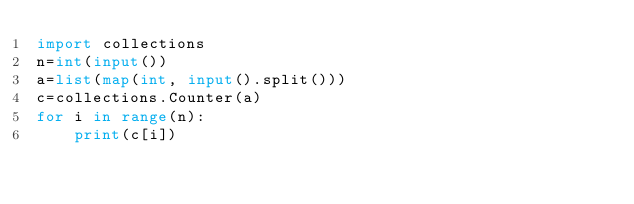<code> <loc_0><loc_0><loc_500><loc_500><_Python_>import collections
n=int(input())
a=list(map(int, input().split()))
c=collections.Counter(a)
for i in range(n):
    print(c[i])</code> 